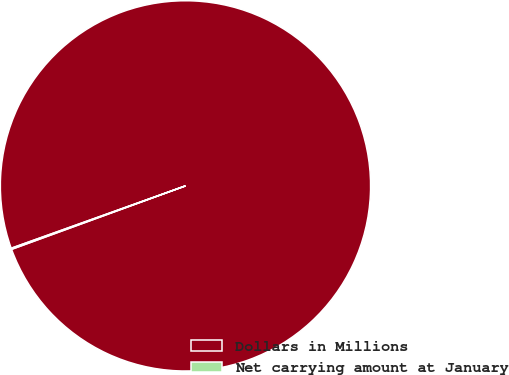<chart> <loc_0><loc_0><loc_500><loc_500><pie_chart><fcel>Dollars in Millions<fcel>Net carrying amount at January<nl><fcel>99.9%<fcel>0.1%<nl></chart> 